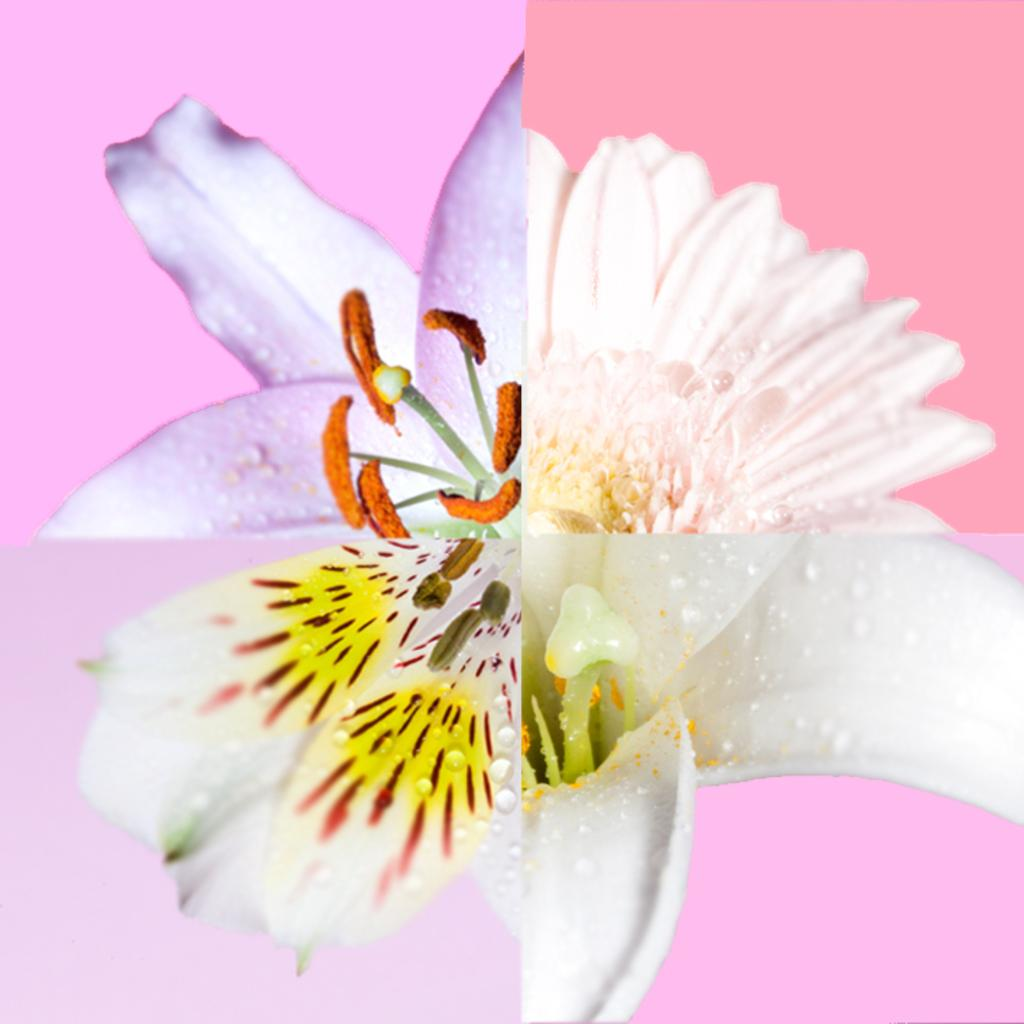What type of artwork is depicted in the image? The image is a collage. What is one of the main elements featured in the collage? There are flowers in the collage. Can you describe the background of the collage? There are different colors in the background of the collage. How many sticks are used to create the scarecrow in the image? There is no scarecrow or sticks present in the image; it is a collage featuring flowers and different colors in the background. 